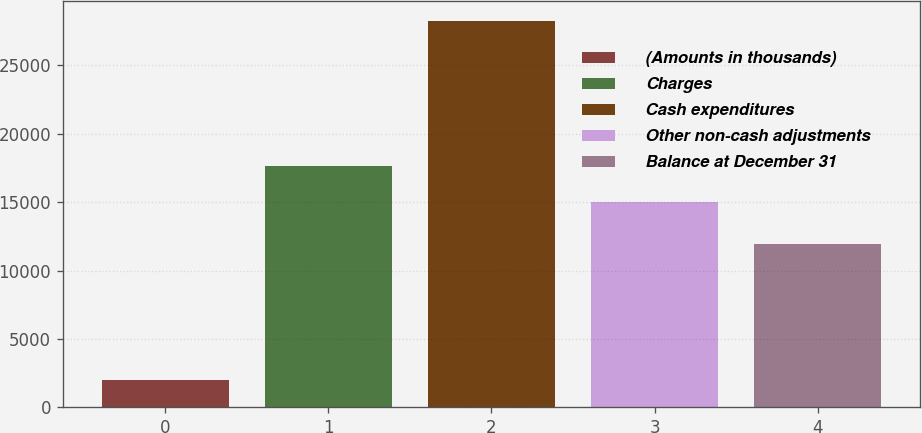Convert chart. <chart><loc_0><loc_0><loc_500><loc_500><bar_chart><fcel>(Amounts in thousands)<fcel>Charges<fcel>Cash expenditures<fcel>Other non-cash adjustments<fcel>Balance at December 31<nl><fcel>2018<fcel>17656.9<fcel>28267<fcel>15032<fcel>11927<nl></chart> 